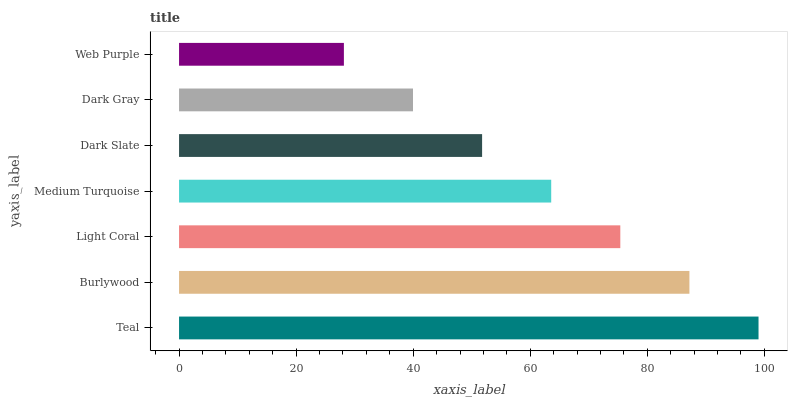Is Web Purple the minimum?
Answer yes or no. Yes. Is Teal the maximum?
Answer yes or no. Yes. Is Burlywood the minimum?
Answer yes or no. No. Is Burlywood the maximum?
Answer yes or no. No. Is Teal greater than Burlywood?
Answer yes or no. Yes. Is Burlywood less than Teal?
Answer yes or no. Yes. Is Burlywood greater than Teal?
Answer yes or no. No. Is Teal less than Burlywood?
Answer yes or no. No. Is Medium Turquoise the high median?
Answer yes or no. Yes. Is Medium Turquoise the low median?
Answer yes or no. Yes. Is Teal the high median?
Answer yes or no. No. Is Burlywood the low median?
Answer yes or no. No. 